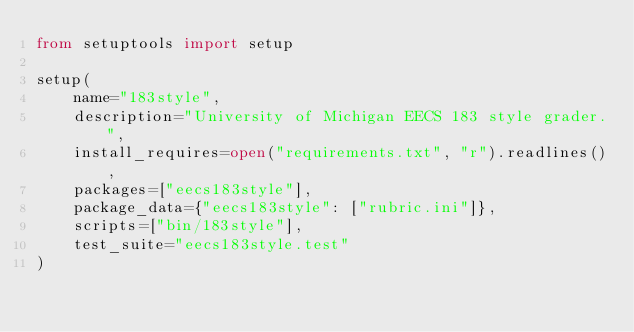Convert code to text. <code><loc_0><loc_0><loc_500><loc_500><_Python_>from setuptools import setup

setup(
    name="183style",
    description="University of Michigan EECS 183 style grader.",
    install_requires=open("requirements.txt", "r").readlines(),
    packages=["eecs183style"],
    package_data={"eecs183style": ["rubric.ini"]},
    scripts=["bin/183style"],
    test_suite="eecs183style.test"
)
</code> 